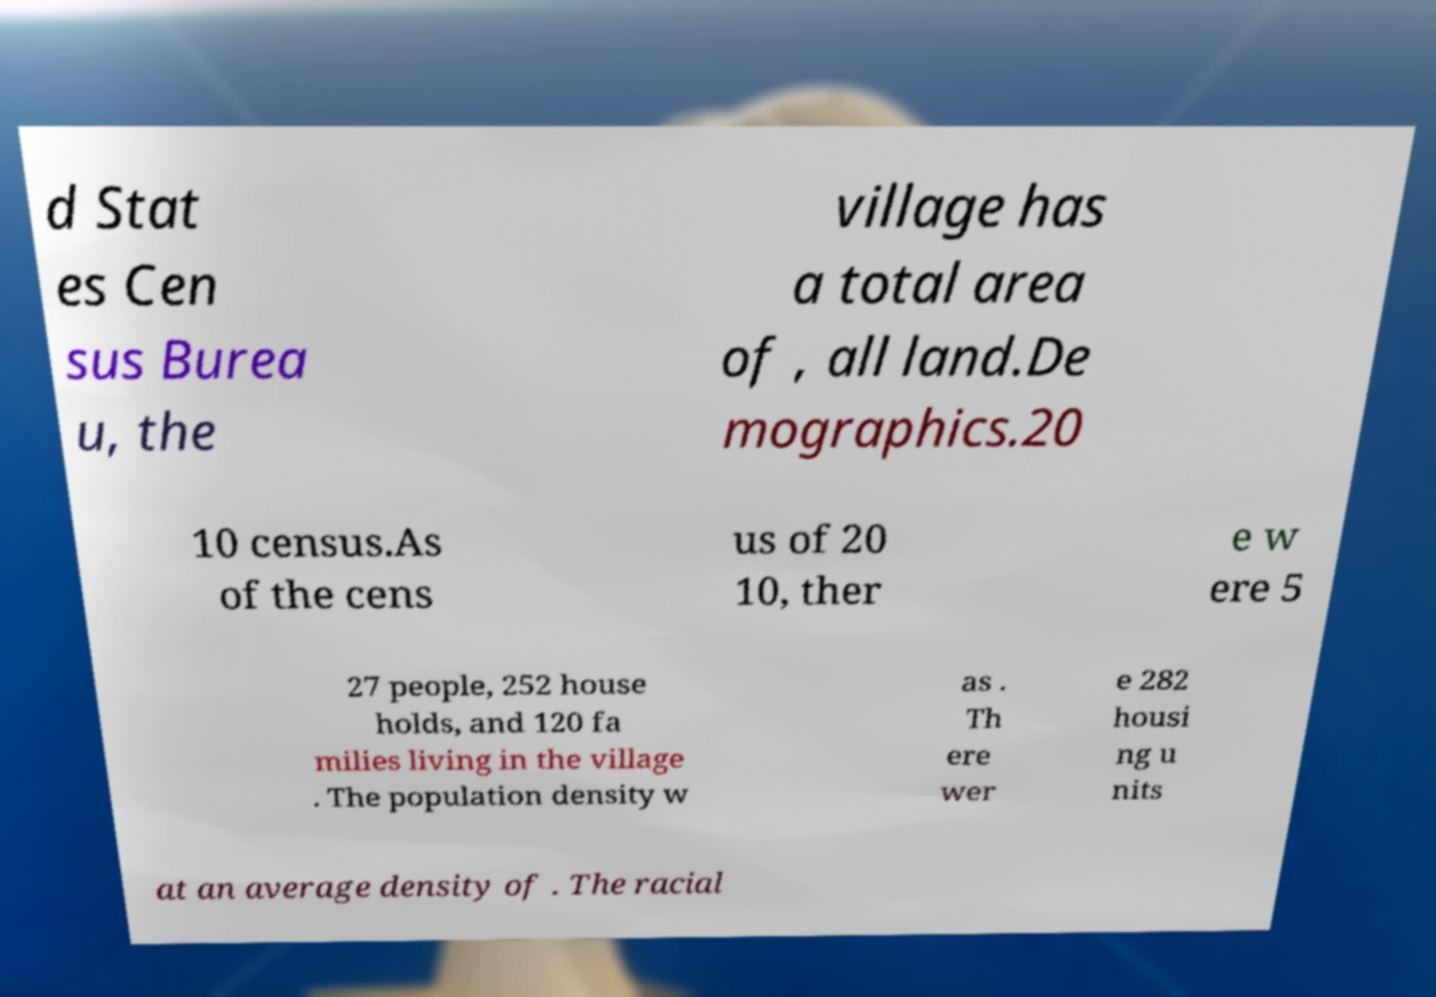Can you accurately transcribe the text from the provided image for me? d Stat es Cen sus Burea u, the village has a total area of , all land.De mographics.20 10 census.As of the cens us of 20 10, ther e w ere 5 27 people, 252 house holds, and 120 fa milies living in the village . The population density w as . Th ere wer e 282 housi ng u nits at an average density of . The racial 